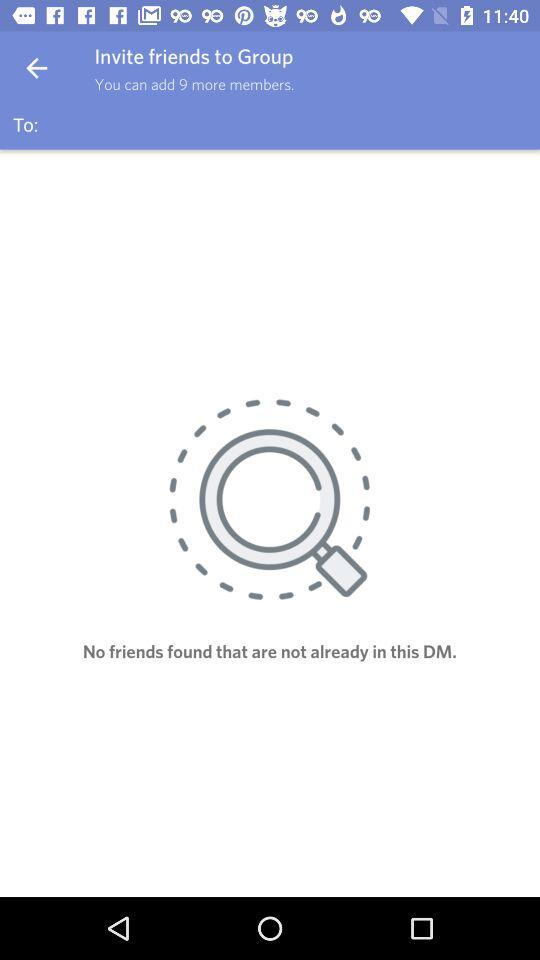How many more members can be added to the group?
Answer the question using a single word or phrase. 9 